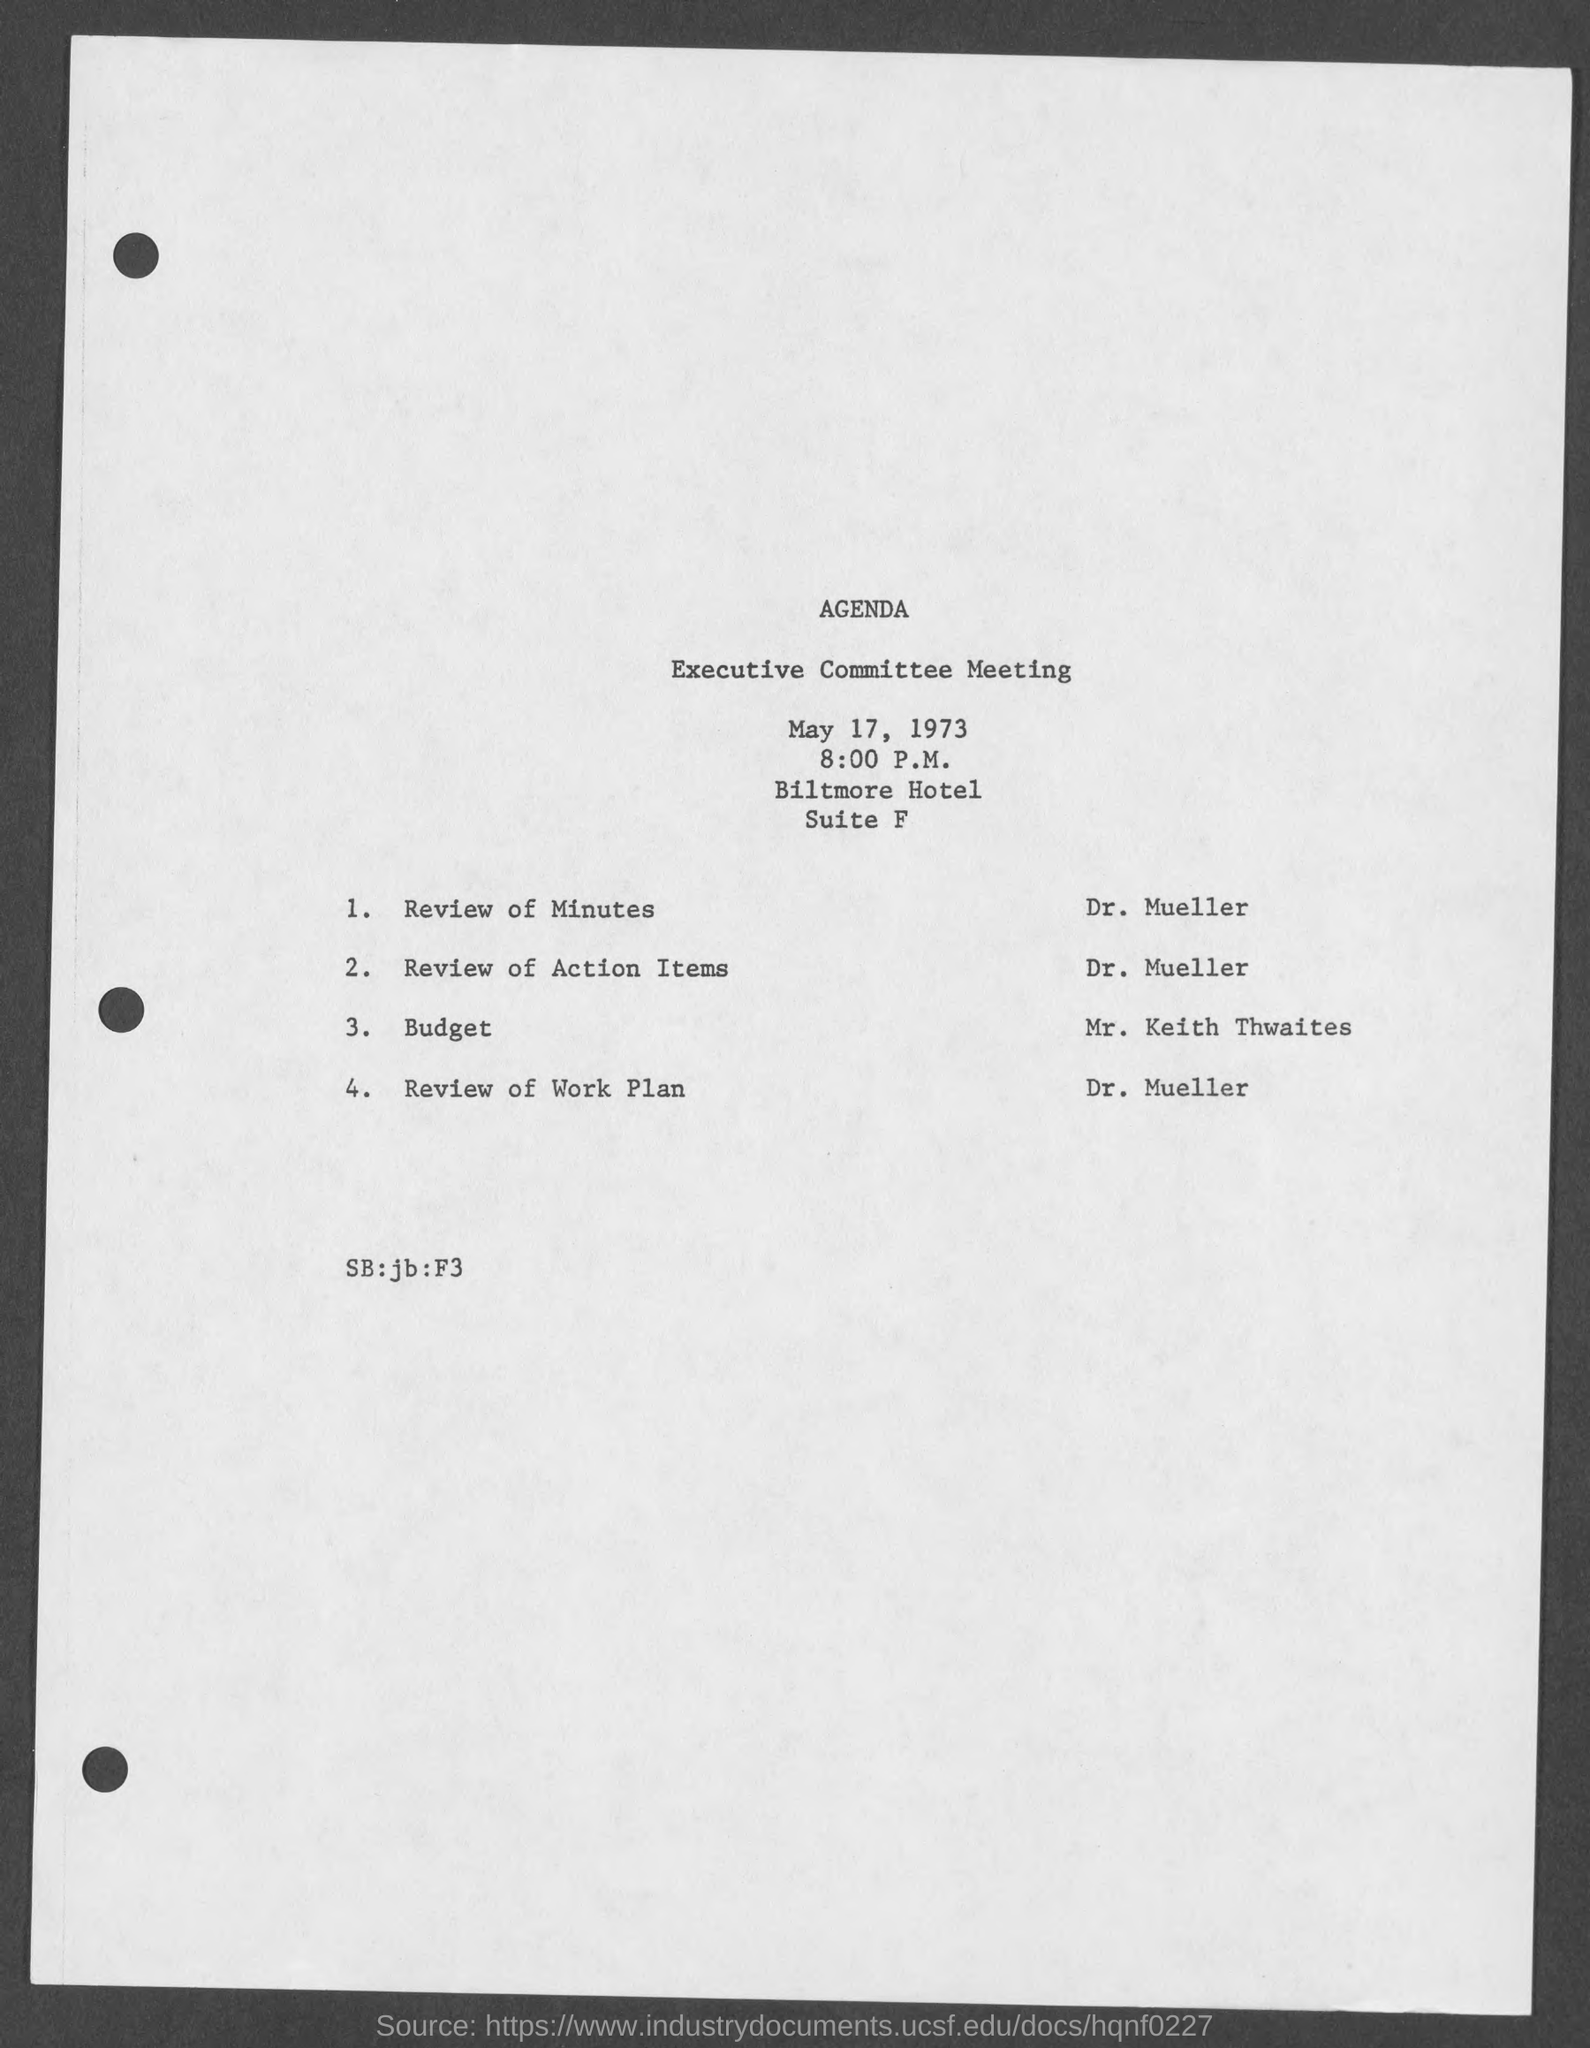Point out several critical features in this image. The review of minutes is conducted by Dr. Mueller. The Executive Committee meeting is scheduled to begin at 8:00 p.m. The budget is prepared and submitted by Mr. Keith Thwaites. The review of action items is done by Dr. Mueller. 